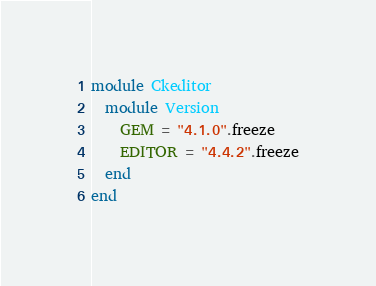<code> <loc_0><loc_0><loc_500><loc_500><_Ruby_>module Ckeditor
  module Version
    GEM = "4.1.0".freeze
    EDITOR = "4.4.2".freeze
  end
end
</code> 